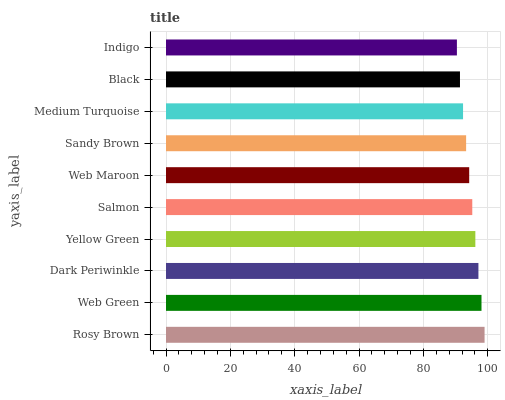Is Indigo the minimum?
Answer yes or no. Yes. Is Rosy Brown the maximum?
Answer yes or no. Yes. Is Web Green the minimum?
Answer yes or no. No. Is Web Green the maximum?
Answer yes or no. No. Is Rosy Brown greater than Web Green?
Answer yes or no. Yes. Is Web Green less than Rosy Brown?
Answer yes or no. Yes. Is Web Green greater than Rosy Brown?
Answer yes or no. No. Is Rosy Brown less than Web Green?
Answer yes or no. No. Is Salmon the high median?
Answer yes or no. Yes. Is Web Maroon the low median?
Answer yes or no. Yes. Is Sandy Brown the high median?
Answer yes or no. No. Is Black the low median?
Answer yes or no. No. 